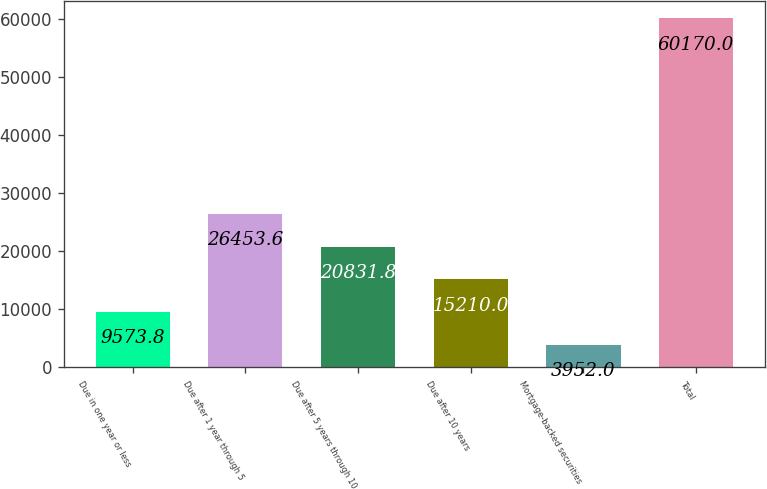Convert chart. <chart><loc_0><loc_0><loc_500><loc_500><bar_chart><fcel>Due in one year or less<fcel>Due after 1 year through 5<fcel>Due after 5 years through 10<fcel>Due after 10 years<fcel>Mortgage-backed securities<fcel>Total<nl><fcel>9573.8<fcel>26453.6<fcel>20831.8<fcel>15210<fcel>3952<fcel>60170<nl></chart> 